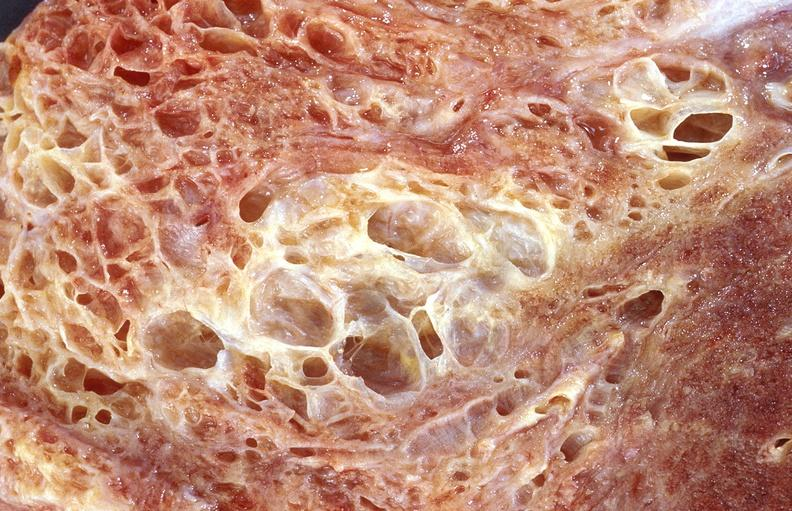what is present?
Answer the question using a single word or phrase. Respiratory 